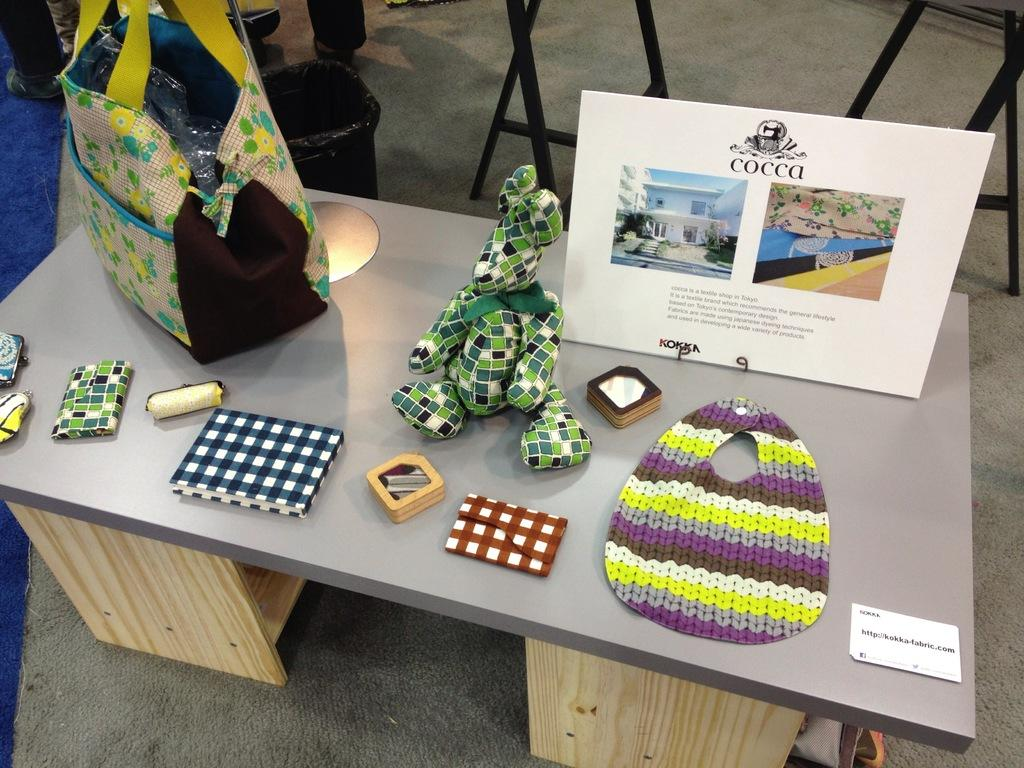What type of table is in the image? There is a wooden table in the image. What items can be seen on the wooden table? There are frames, bags, toys, a wallet, and a book on the wooden table. Are there any other objects on the wooden table? Yes, there are other objects on the wooden table. What can be seen behind the wooden table? There is a black color dustbin behind the table. Can you describe the window in the image? There is no window present in the image; it only features a wooden table, various items on the table, and a black color dustbin behind the table. 